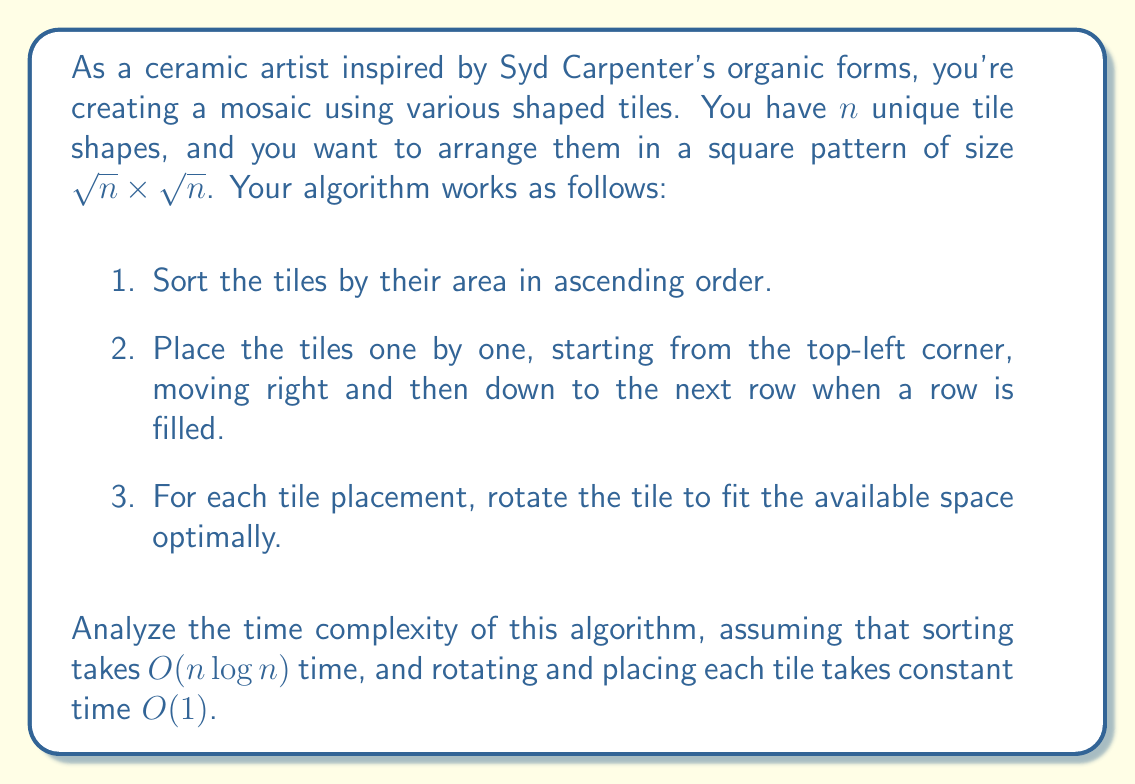Give your solution to this math problem. Let's break down the algorithm and analyze each step:

1. Sorting the tiles:
   The sorting step uses a comparison-based sorting algorithm, which has a time complexity of $O(n \log n)$ for $n$ tiles.

2. Placing the tiles:
   We need to place all $n$ tiles, and for each tile, we perform a constant-time operation (rotating and placing). This step takes $O(n)$ time.

3. Overall algorithm:
   The total time complexity is the sum of the sorting and placing steps:
   $$T(n) = O(n \log n) + O(n)$$

   Since $O(n \log n)$ grows faster than $O(n)$ for large $n$, we can simplify this to:
   $$T(n) = O(n \log n)$$

It's worth noting that the square root calculation for determining the grid size doesn't affect the overall time complexity, as it's only used to determine the layout and doesn't impact the number of operations performed on the tiles themselves.

Therefore, the dominant factor in the time complexity is the initial sorting step, making the overall time complexity of the algorithm $O(n \log n)$.
Answer: The time complexity of the algorithm is $O(n \log n)$. 